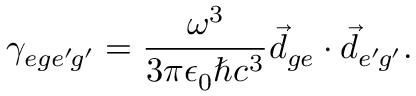<formula> <loc_0><loc_0><loc_500><loc_500>\gamma _ { e g e ^ { \prime } \, g ^ { \prime } } = \frac { \omega ^ { 3 } } { 3 \pi \epsilon _ { 0 } \hbar { c } ^ { 3 } } \vec { d } _ { g e } \cdot \vec { d } _ { e ^ { \prime } \, g ^ { \prime } } .</formula> 